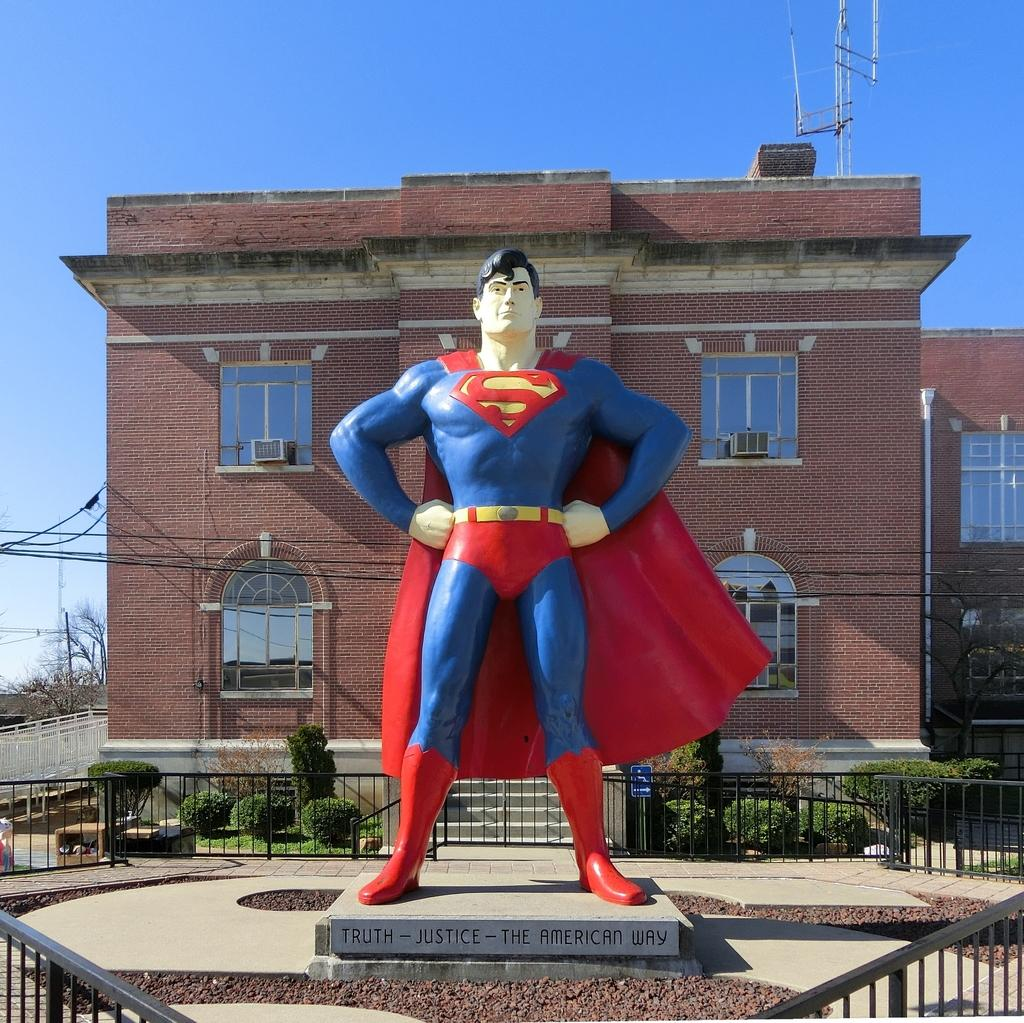What is the main subject of the image? There is a statue of a man in the image. What can be seen in the background of the image? There are buildings, trees, plants, grass, a fence, and the sky visible in the background of the image. How many cubs are playing with the dolls in the image? There are no cubs or dolls present in the image. What color are the socks on the statue's feet? The statue does not have feet, and therefore there are no socks present in the image. 